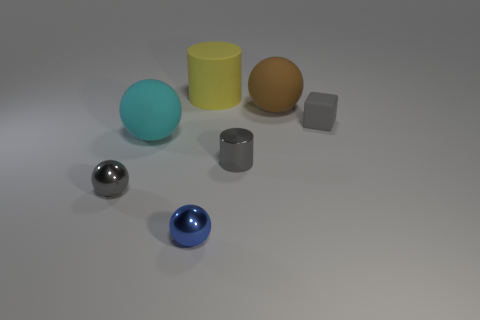There is a small shiny object left of the cyan ball; is it the same shape as the small gray matte thing?
Ensure brevity in your answer.  No. Is there a gray thing that has the same shape as the small blue object?
Your response must be concise. Yes. There is a small ball that is the same color as the tiny rubber cube; what material is it?
Your answer should be compact. Metal. What is the shape of the big thing that is behind the ball that is behind the small gray rubber cube?
Offer a very short reply. Cylinder. How many small balls have the same material as the tiny cylinder?
Provide a short and direct response. 2. There is another large ball that is made of the same material as the large cyan ball; what color is it?
Your answer should be very brief. Brown. What is the size of the rubber sphere that is right of the tiny gray shiny thing on the right side of the tiny blue metal thing that is in front of the gray ball?
Provide a short and direct response. Large. Is the number of large rubber objects less than the number of objects?
Keep it short and to the point. Yes. There is another rubber object that is the same shape as the cyan rubber thing; what is its color?
Offer a terse response. Brown. Are there any things behind the big matte ball to the left of the tiny metal object that is behind the gray metallic ball?
Provide a short and direct response. Yes. 